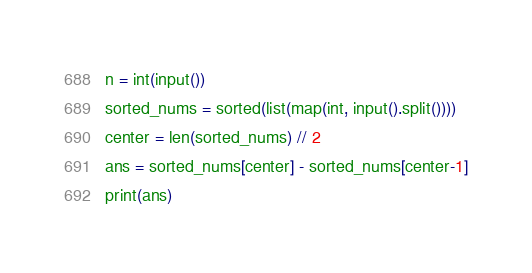<code> <loc_0><loc_0><loc_500><loc_500><_Python_>n = int(input())
sorted_nums = sorted(list(map(int, input().split())))
center = len(sorted_nums) // 2
ans = sorted_nums[center] - sorted_nums[center-1]
print(ans)</code> 